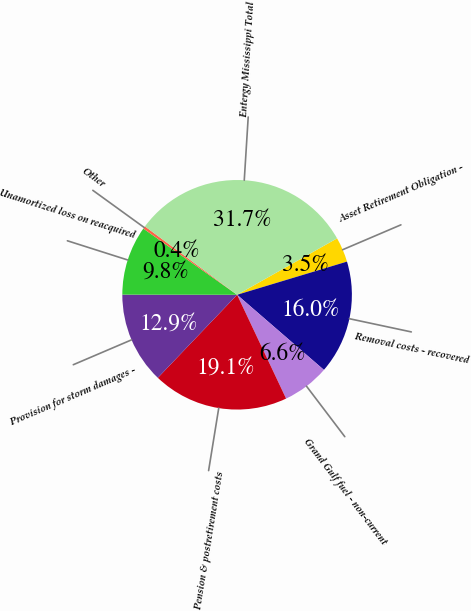Convert chart. <chart><loc_0><loc_0><loc_500><loc_500><pie_chart><fcel>Asset Retirement Obligation -<fcel>Removal costs - recovered<fcel>Grand Gulf fuel - non-current<fcel>Pension & postretirement costs<fcel>Provision for storm damages -<fcel>Unamortized loss on reacquired<fcel>Other<fcel>Entergy Mississippi Total<nl><fcel>3.51%<fcel>16.02%<fcel>6.63%<fcel>19.15%<fcel>12.89%<fcel>9.76%<fcel>0.38%<fcel>31.66%<nl></chart> 